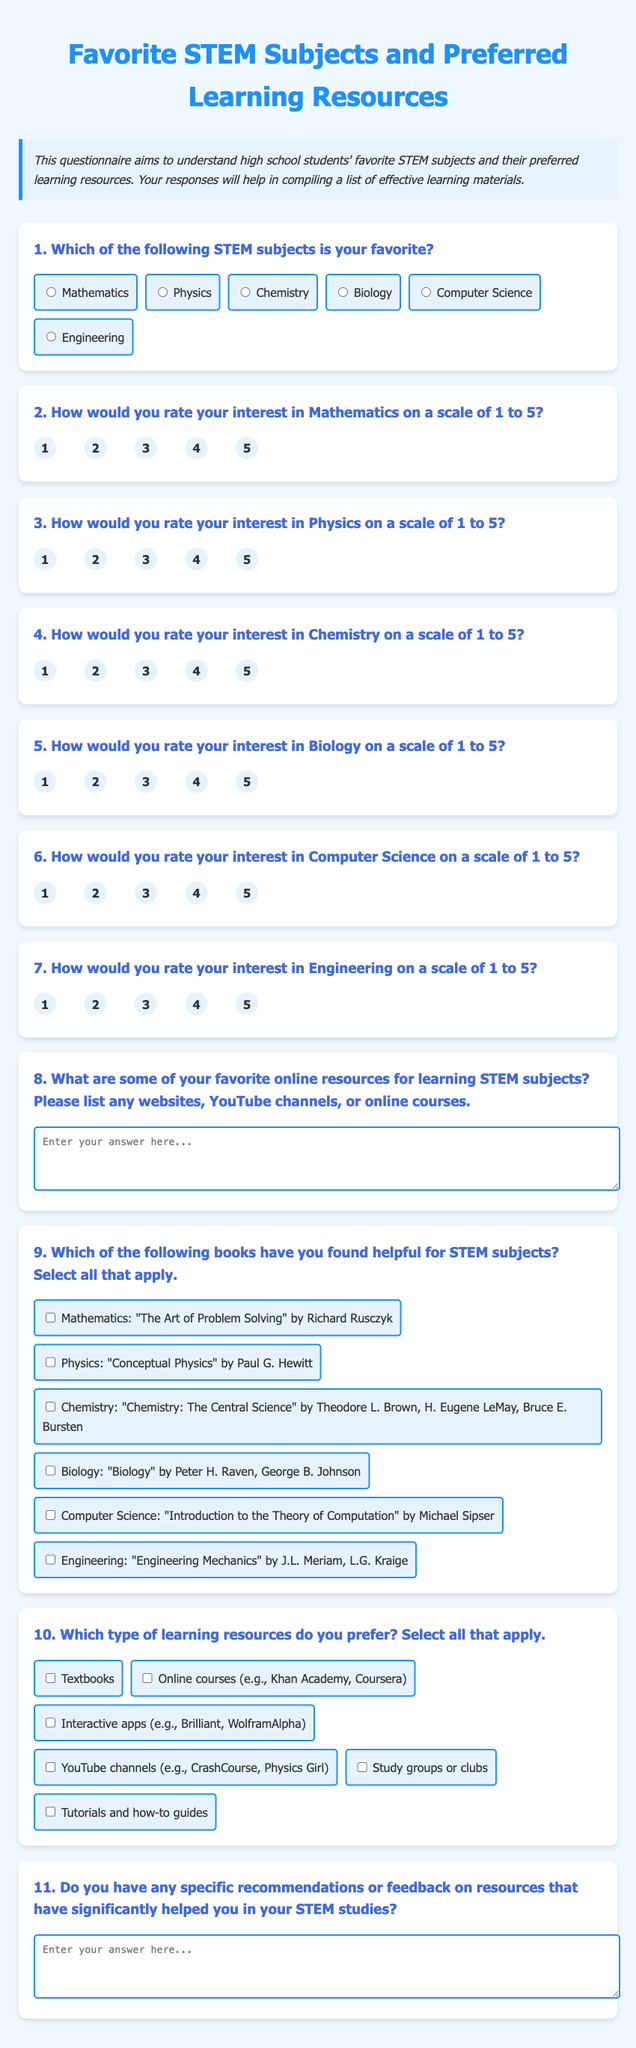What is the title of the questionnaire? The title is specified at the top of the document as "Favorite STEM Subjects and Preferred Learning Resources."
Answer: Favorite STEM Subjects and Preferred Learning Resources How many main questions are there in the questionnaire? After counting the numbered questions in the form, there are eleven questions total.
Answer: 11 Which book is suggested for learning Physics? The document lists "Conceptual Physics" by Paul G. Hewitt as a helpful resource for Physics.
Answer: Conceptual Physics by Paul G. Hewitt What type of learning resource can students select that includes videos? Among the options given for preferred resources, "YouTube channels" is specifically mentioned for video learning.
Answer: YouTube channels Which STEM subject has the highest interest rating options? Each STEM subject rates interest from one to five, indicating the maximum score available for all subjects is five.
Answer: 5 What is the purpose of this questionnaire? The document states that the purpose is to understand students' favorite STEM subjects and their preferred learning resources.
Answer: To understand favorite STEM subjects and preferred learning resources How do students provide feedback on resources they've found helpful? Students can enter their recommendations or feedback for helpful resources in a designated text area at the end of the questionnaire.
Answer: In a designated text area Which online course option is mentioned in the preferred learning resources? The document lists "Online courses (e.g., Khan Academy, Coursera)" as a preferred type of learning resource.
Answer: Online courses (e.g., Khan Academy, Coursera) What is the background color of the document? The background color of the document is specified in the style as a light blue shade ("#f0f8ff").
Answer: Light blue 